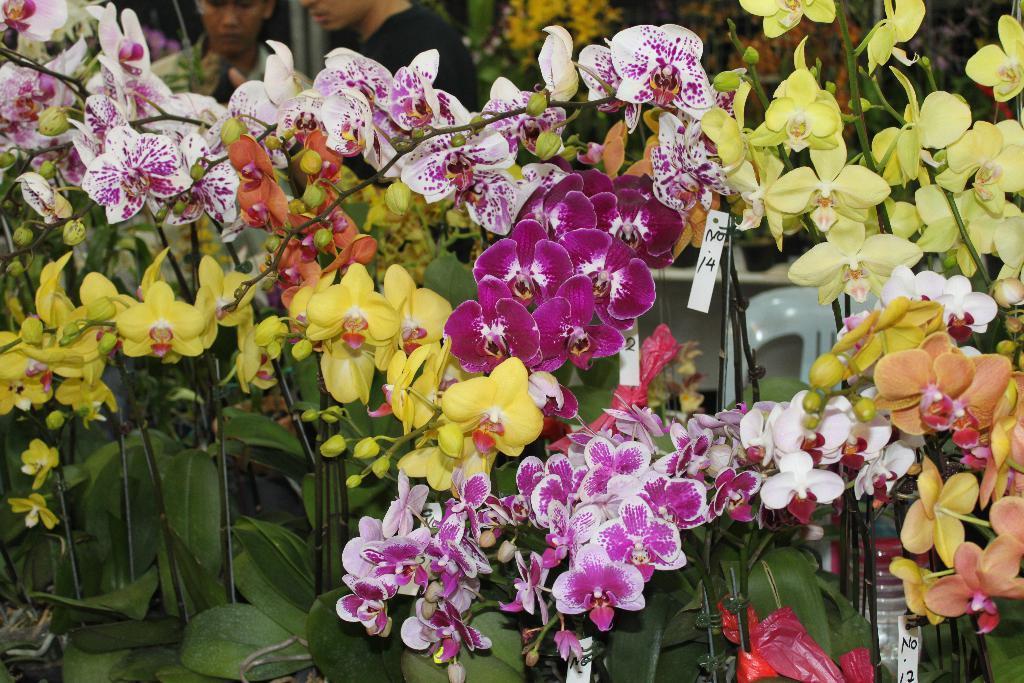Describe this image in one or two sentences. In this picture we can see there are plants with flowers. Behind the plants there is a chair and two persons. 